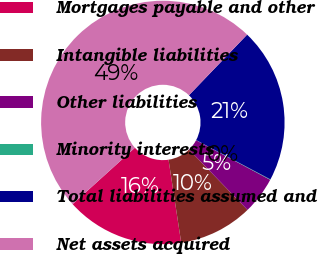Convert chart. <chart><loc_0><loc_0><loc_500><loc_500><pie_chart><fcel>Mortgages payable and other<fcel>Intangible liabilities<fcel>Other liabilities<fcel>Minority interests<fcel>Total liabilities assumed and<fcel>Net assets acquired<nl><fcel>15.7%<fcel>9.83%<fcel>4.95%<fcel>0.06%<fcel>20.58%<fcel>48.88%<nl></chart> 